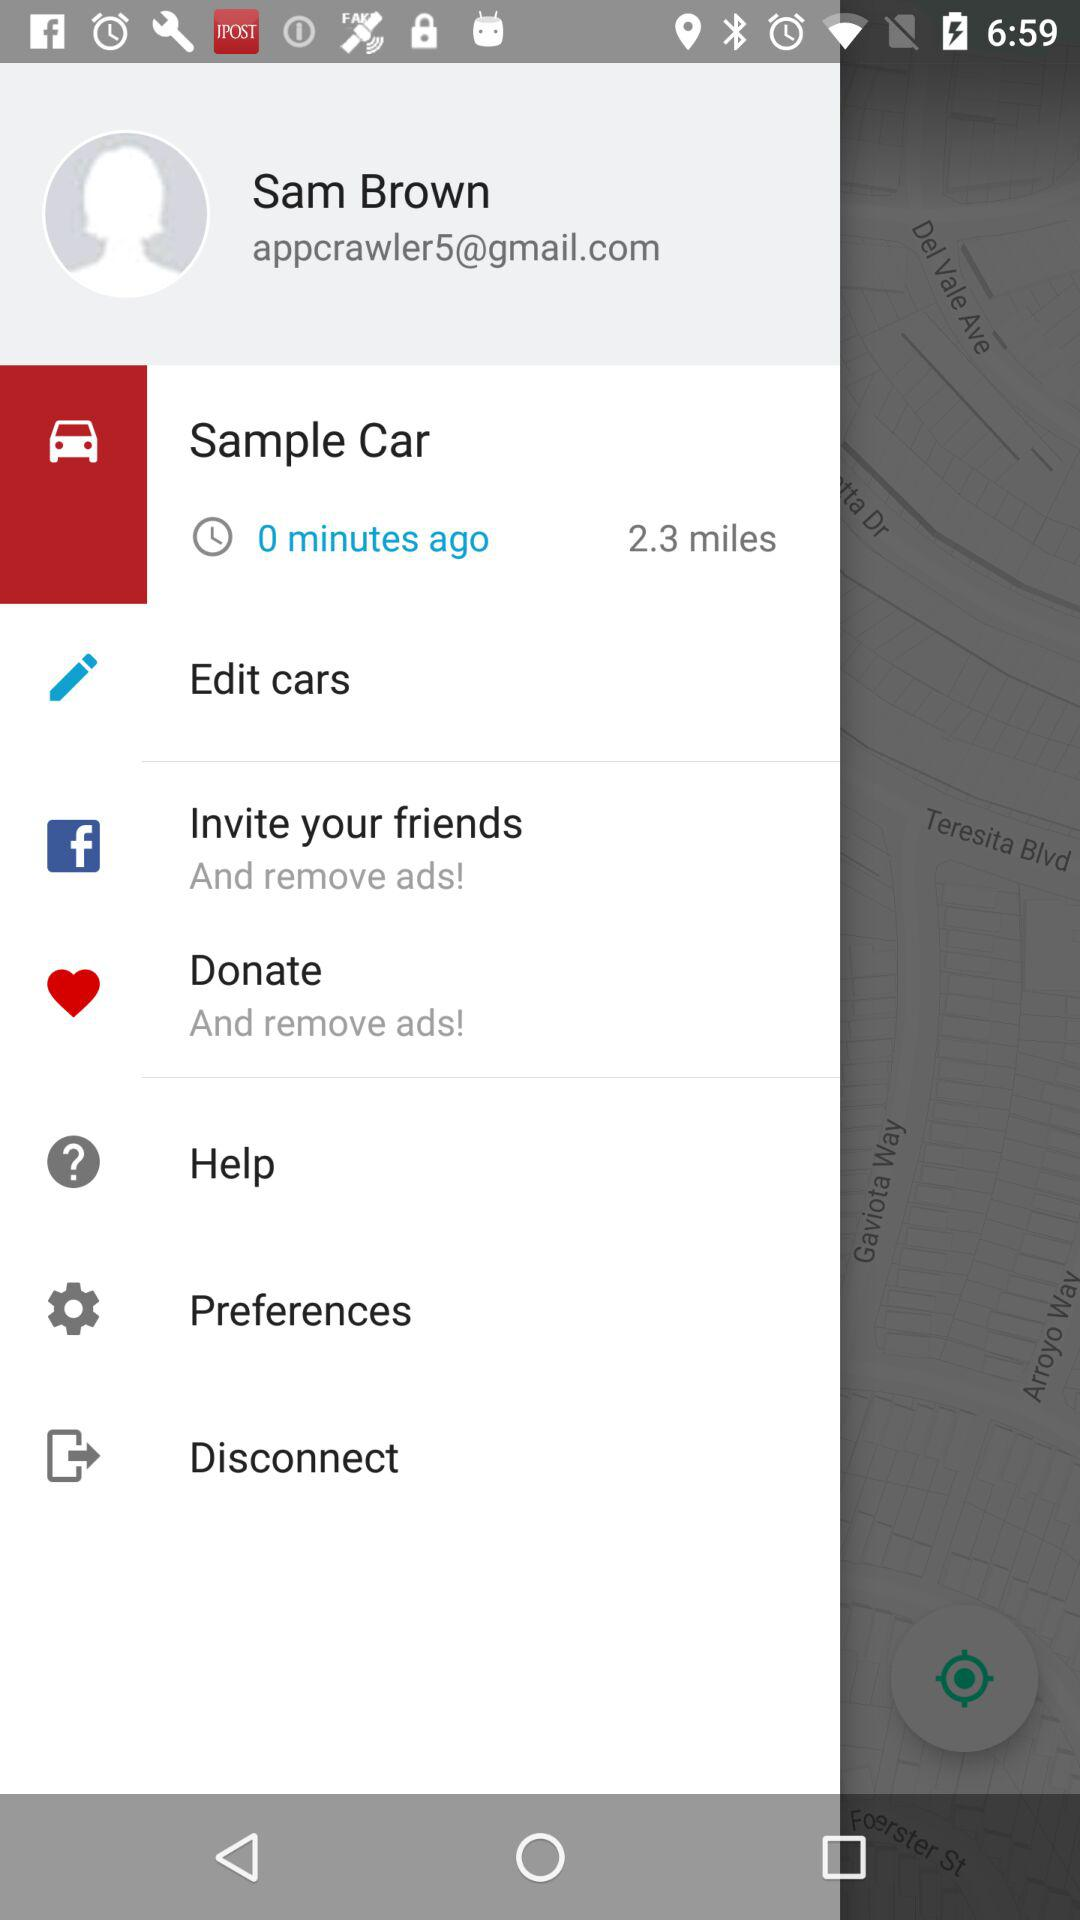What is the email address? The email address is appcrawler5@gmail.com. 